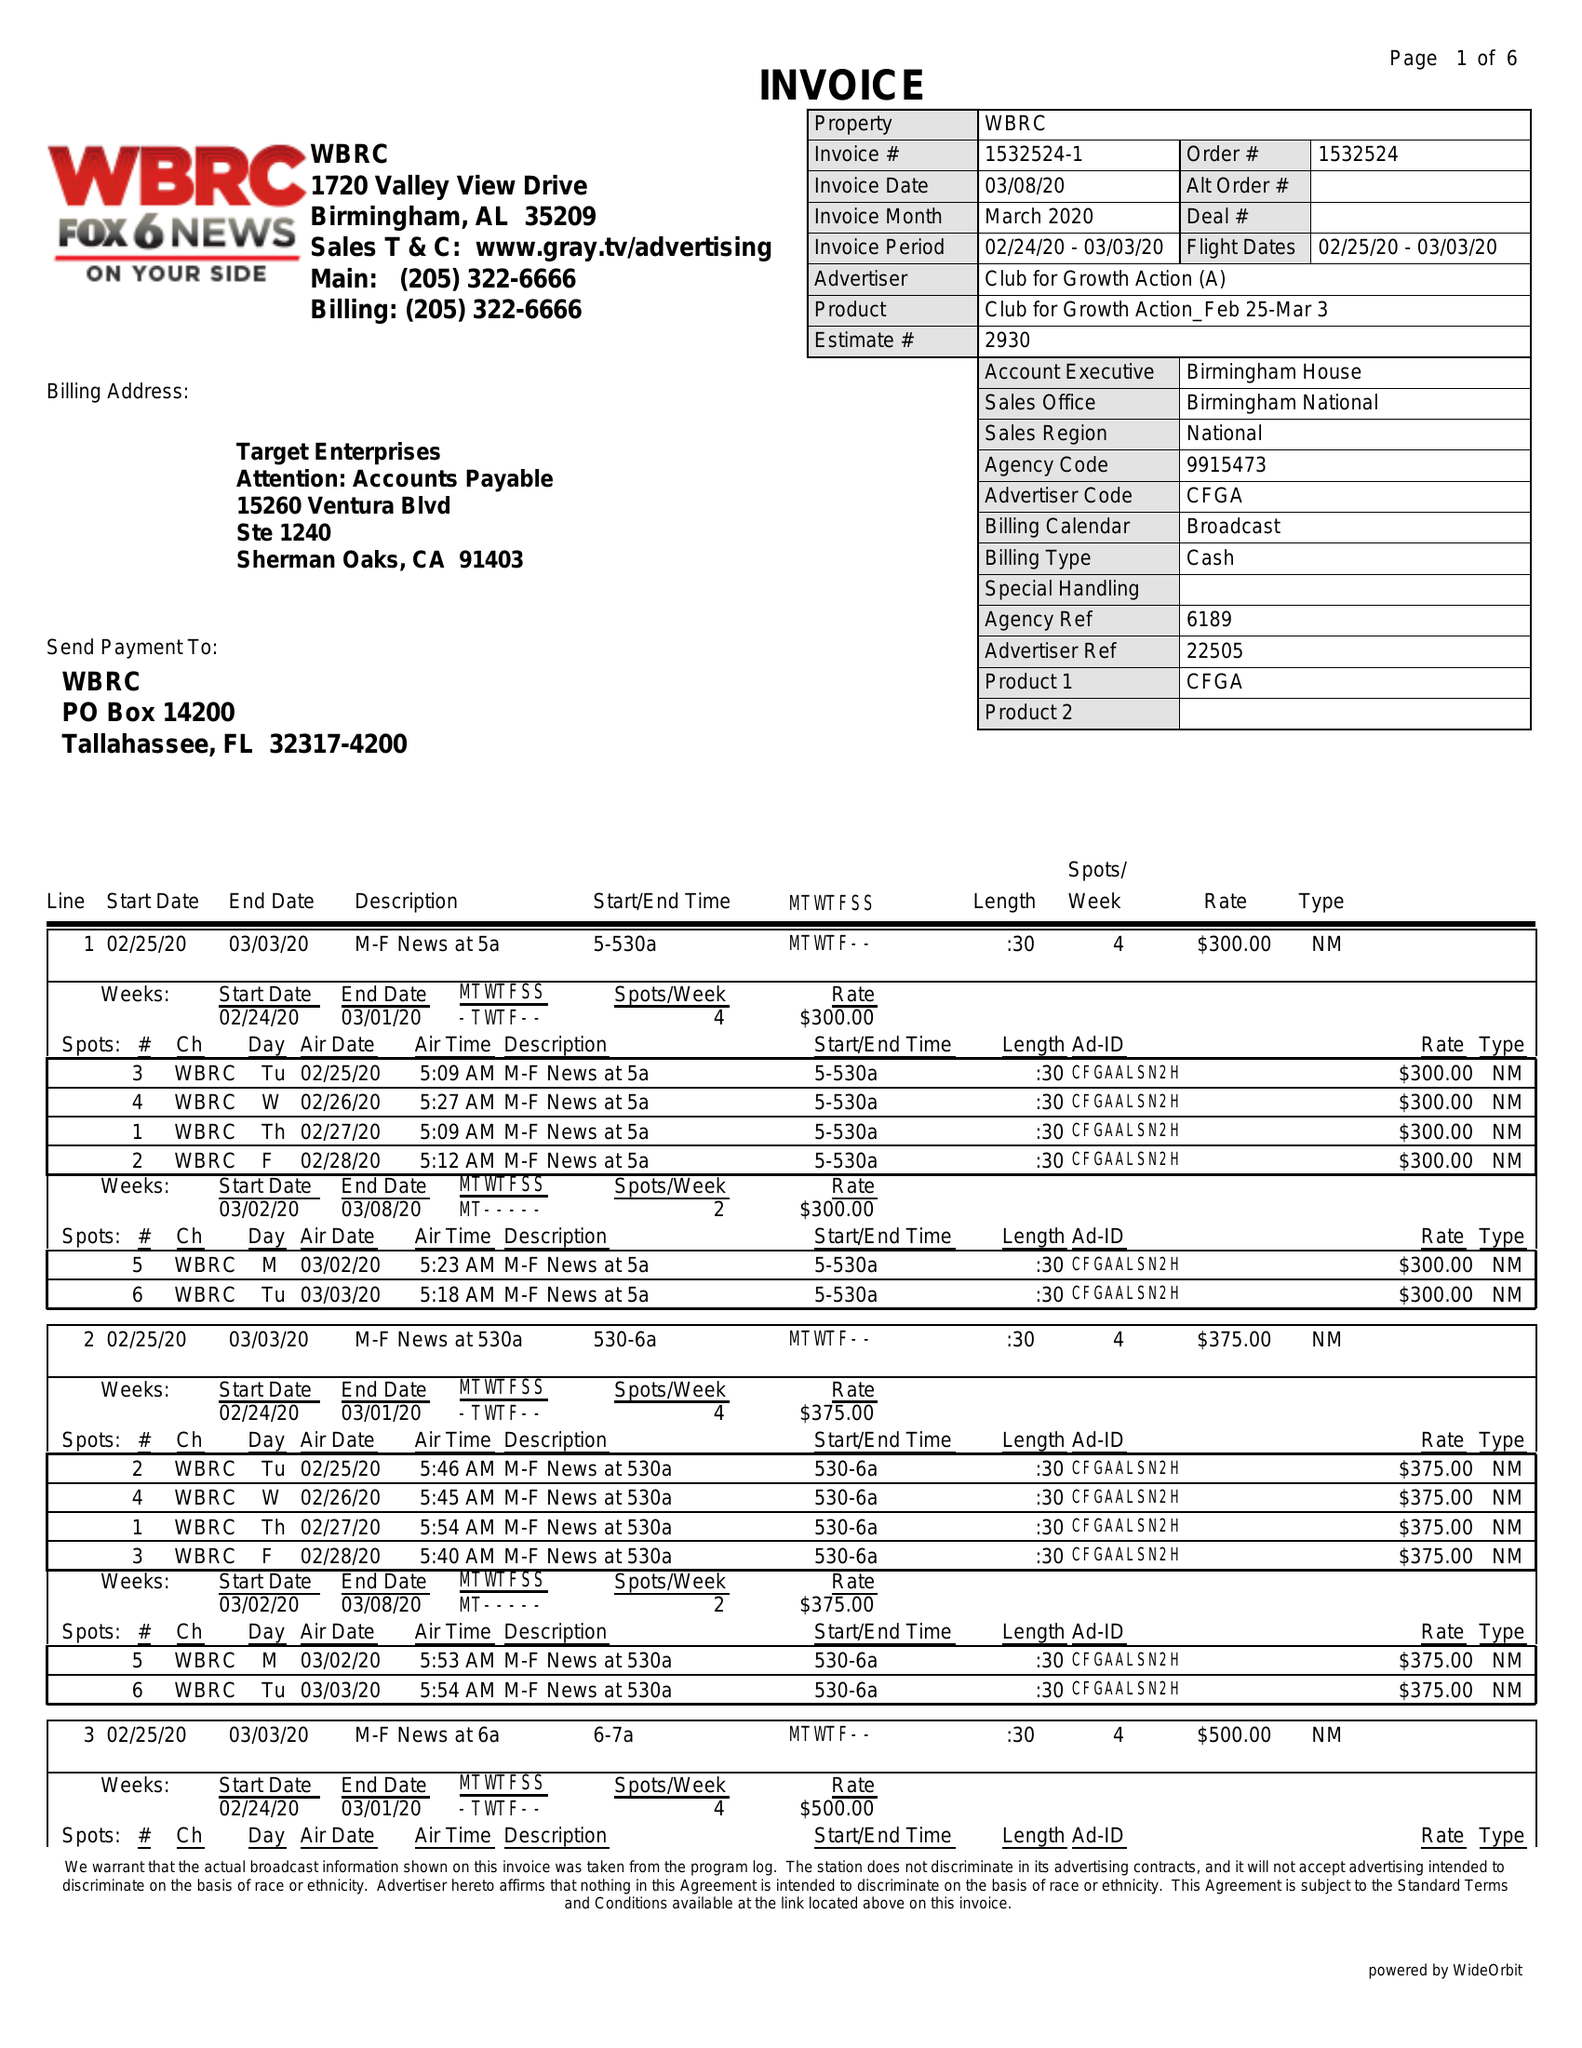What is the value for the flight_to?
Answer the question using a single word or phrase. 03/03/20 